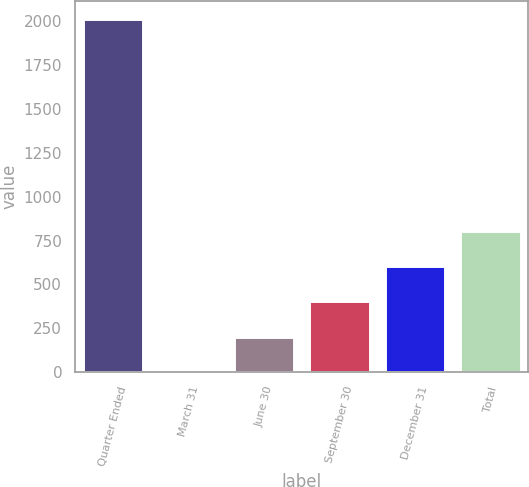Convert chart. <chart><loc_0><loc_0><loc_500><loc_500><bar_chart><fcel>Quarter Ended<fcel>March 31<fcel>June 30<fcel>September 30<fcel>December 31<fcel>Total<nl><fcel>2014<fcel>0.34<fcel>201.71<fcel>403.08<fcel>604.45<fcel>805.82<nl></chart> 